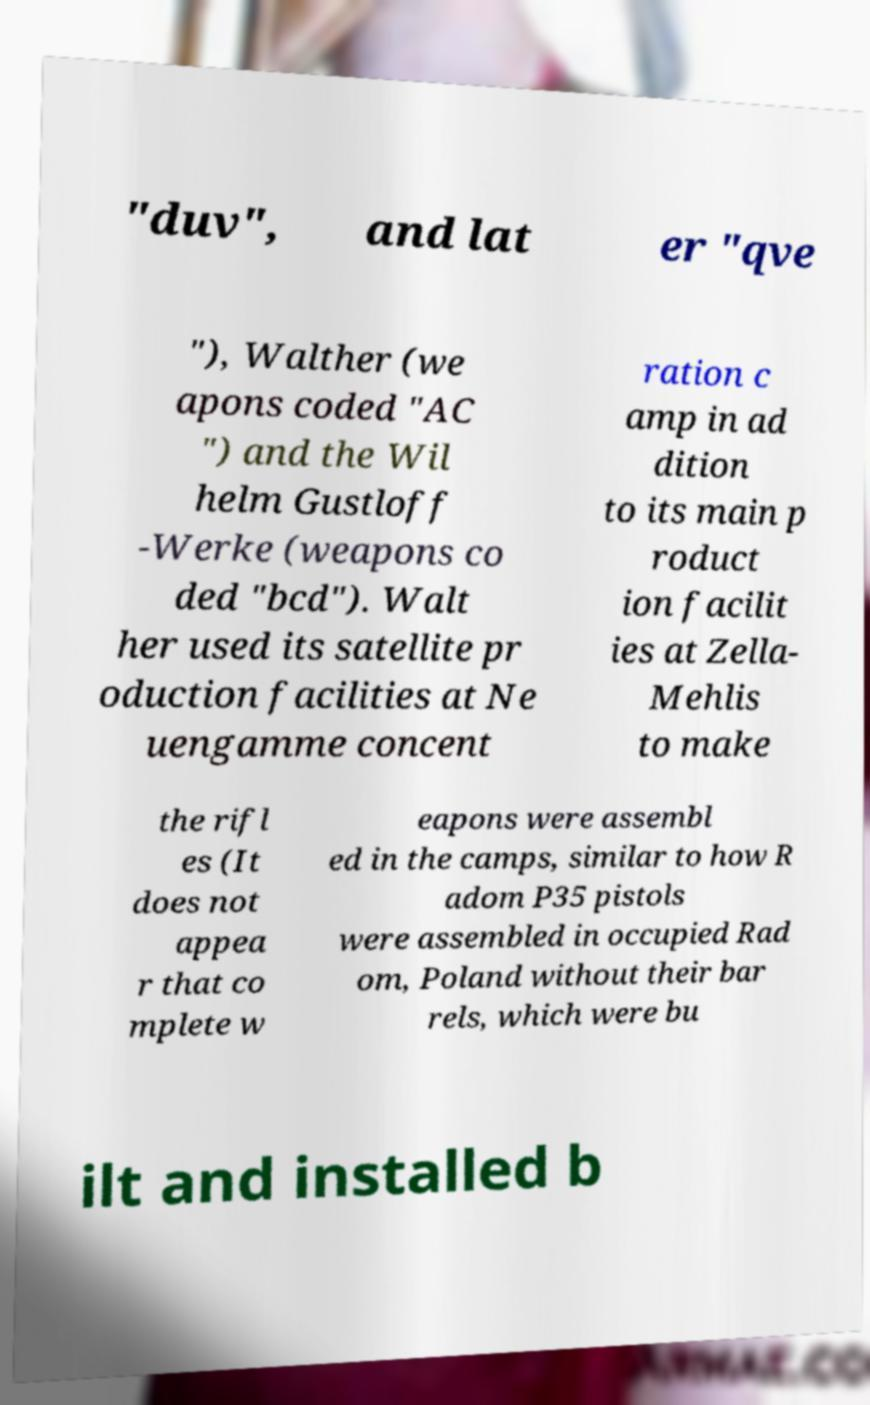I need the written content from this picture converted into text. Can you do that? "duv", and lat er "qve "), Walther (we apons coded "AC ") and the Wil helm Gustloff -Werke (weapons co ded "bcd"). Walt her used its satellite pr oduction facilities at Ne uengamme concent ration c amp in ad dition to its main p roduct ion facilit ies at Zella- Mehlis to make the rifl es (It does not appea r that co mplete w eapons were assembl ed in the camps, similar to how R adom P35 pistols were assembled in occupied Rad om, Poland without their bar rels, which were bu ilt and installed b 